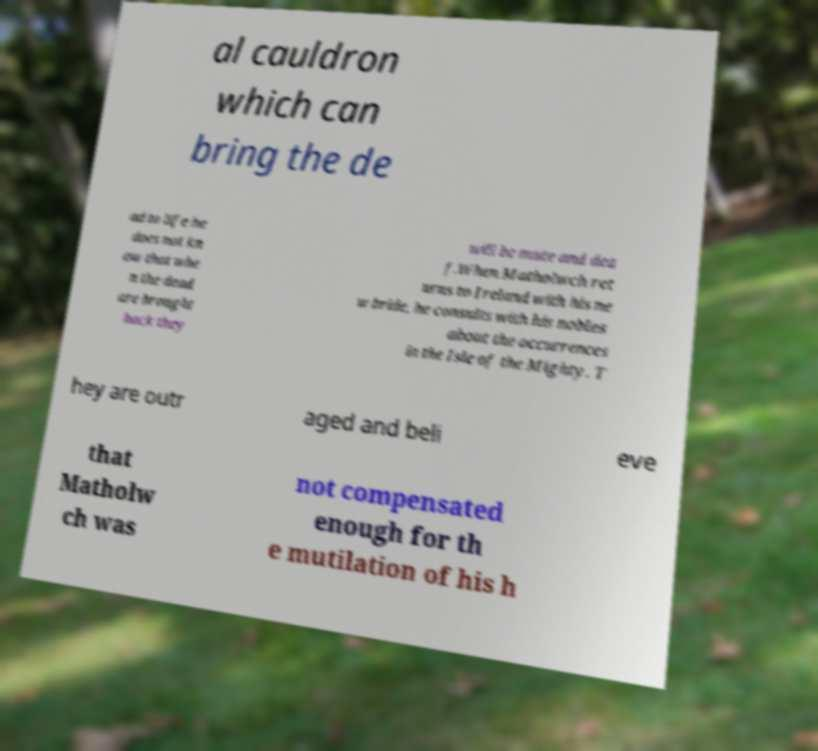Can you accurately transcribe the text from the provided image for me? al cauldron which can bring the de ad to life he does not kn ow that whe n the dead are brought back they will be mute and dea f.When Matholwch ret urns to Ireland with his ne w bride, he consults with his nobles about the occurrences in the Isle of the Mighty. T hey are outr aged and beli eve that Matholw ch was not compensated enough for th e mutilation of his h 